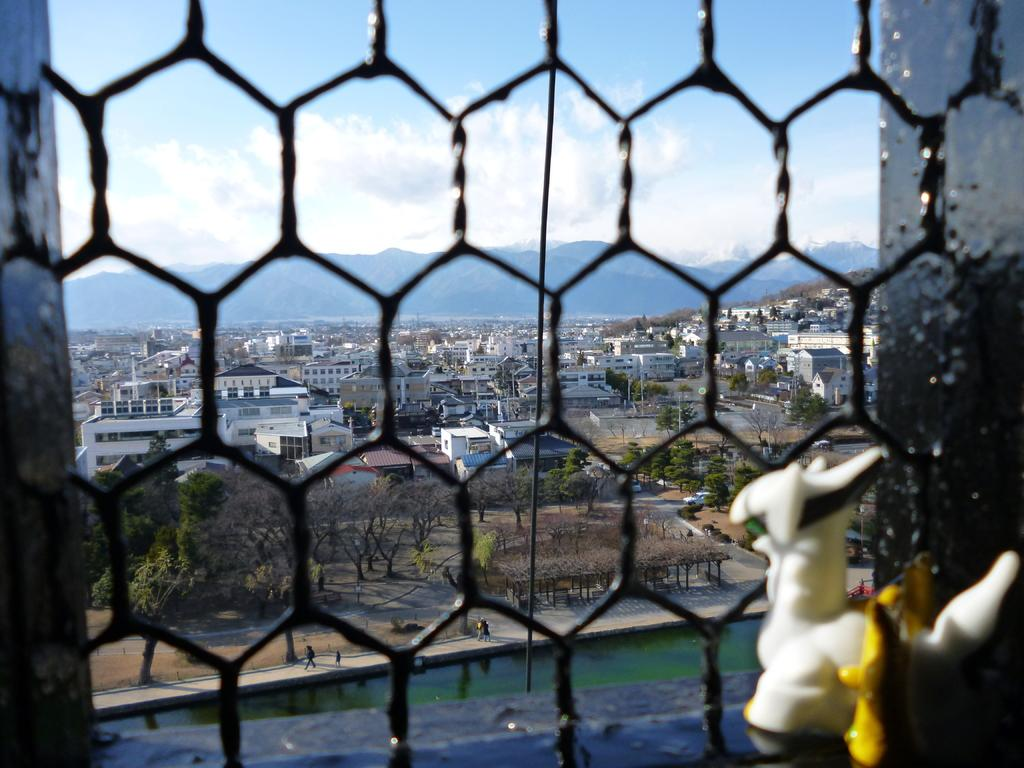What can be seen through the window in the image? Water, people, trees, plants, a road, vehicles, poles, buildings, hills, the sky, and clouds are visible through the window in the image. Can you describe the landscape visible from the window? The landscape includes water, trees, plants, a road, vehicles, poles, buildings, hills, the sky, and clouds. Are there any signs of human activity visible from the window? Yes, there are vehicles and buildings visible from the window, which are signs of human activity. What type of weather can be inferred from the presence of clouds in the image? The presence of clouds suggests that the weather might be partly cloudy or overcast. What type of farm animals can be seen grazing in the image? There is no farm or farm animals present in the image. What color is the glove that the person is wearing in the image? There is no glove or person visible in the image. 